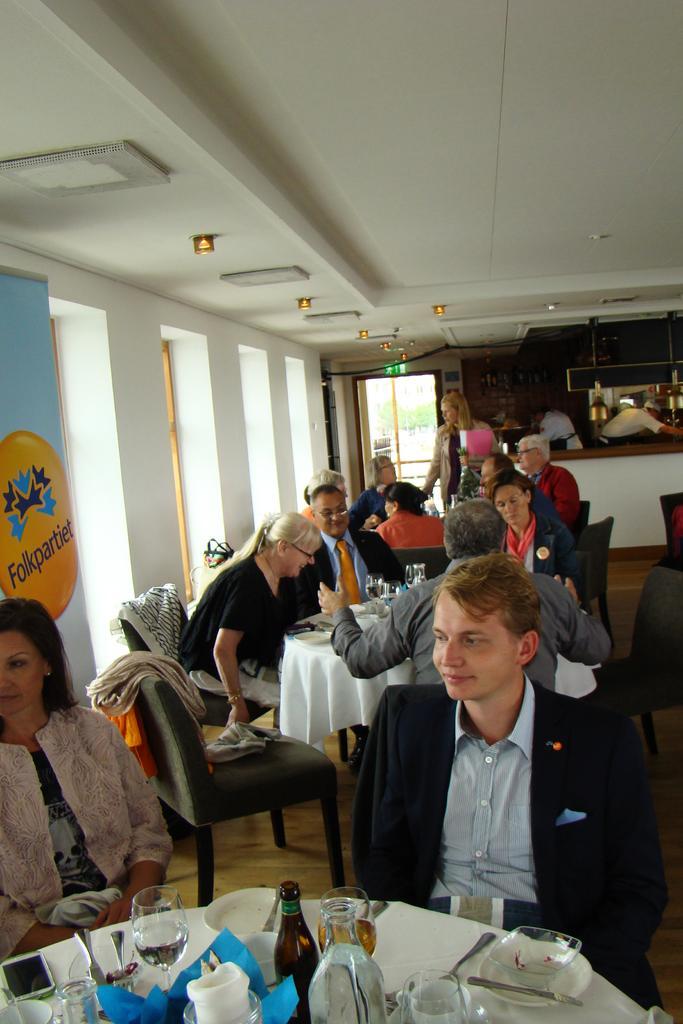How would you summarize this image in a sentence or two? This picture is clicked inside a restaurant. There are many people sitting on chairs at the tables. On the table there are bottles, glasses, mobile phone, plates and spoons. There are lights to the ceiling. In the background there is wall and glass door. 